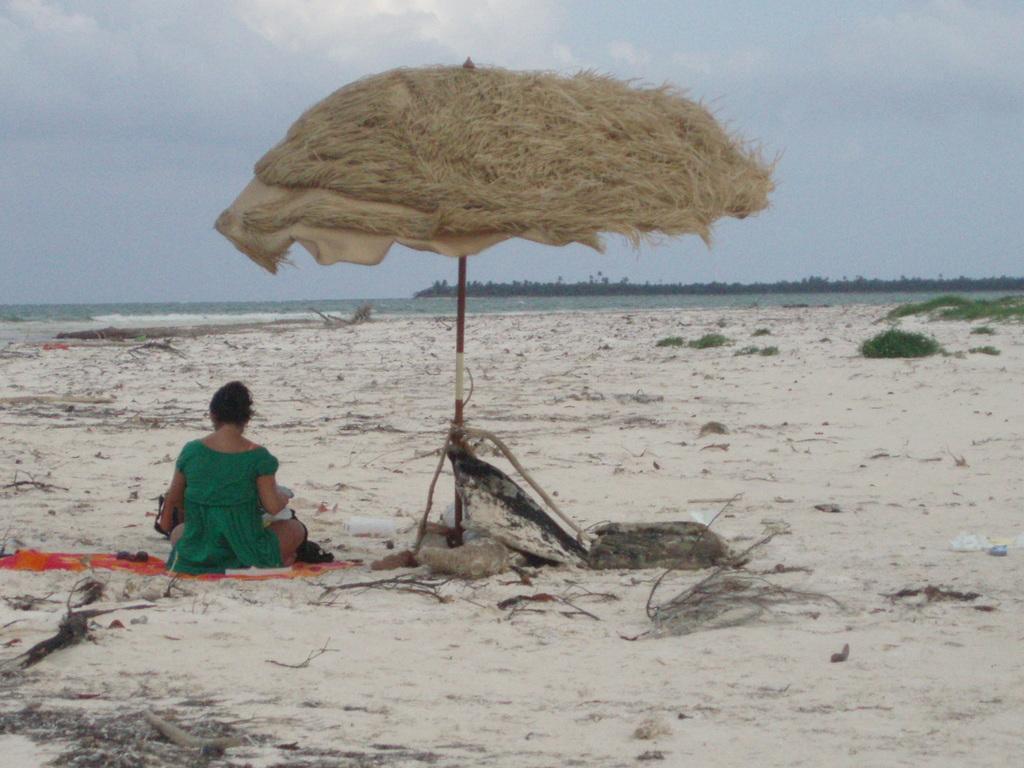Describe this image in one or two sentences. In this image there is a woman who is sitting on the sand. Beside her there is an umbrella on which there is dry grass. In the background there is an ocean. In the ocean there is an island. At the bottom there is sand on which there are wooden sticks and some plants. 